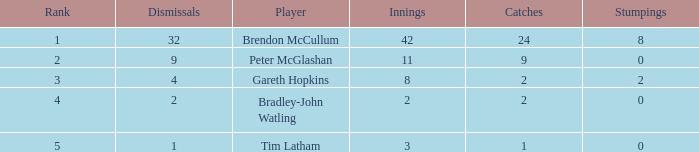Can you provide the ranks for all dismissals worth 4 points? 3.0. 